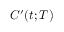Convert formula to latex. <formula><loc_0><loc_0><loc_500><loc_500>C ^ { \prime } ( t ; T )</formula> 